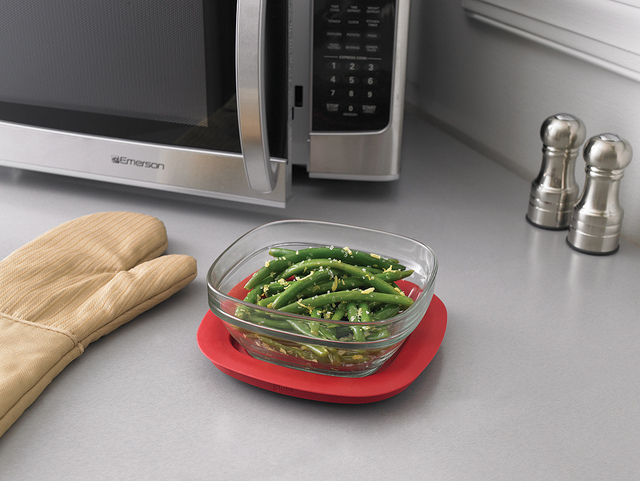What materials are the salt and pepper shakers made of? The salt and pepper shakers in the background look to be made of a shiny metal, likely stainless steel, which matches the sleek, modern aesthetic of the kitchen. What are some potential health benefits of eating green vegetables like the ones in the bowl? Green vegetables are rich in vitamins, minerals, and fiber. They can contribute to a healthy diet by improving digestion, lowering the risk of chronic diseases, and aiding in weight management. 